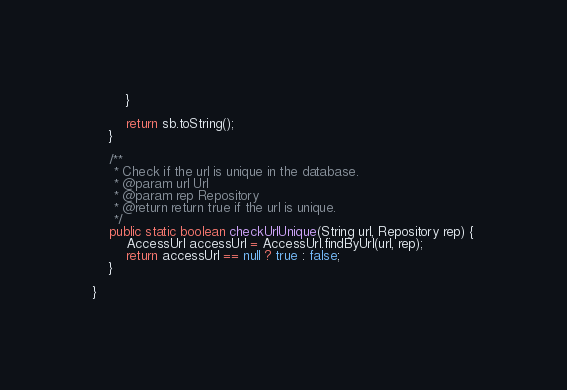Convert code to text. <code><loc_0><loc_0><loc_500><loc_500><_Java_>        }

        return sb.toString();
    }

    /**
     * Check if the url is unique in the database.
     * @param url Url
     * @param rep Repository
     * @return return true if the url is unique.
     */
    public static boolean checkUrlUnique(String url, Repository rep) {
        AccessUrl accessUrl = AccessUrl.findByUrl(url, rep);
        return accessUrl == null ? true : false;
    }

}
</code> 